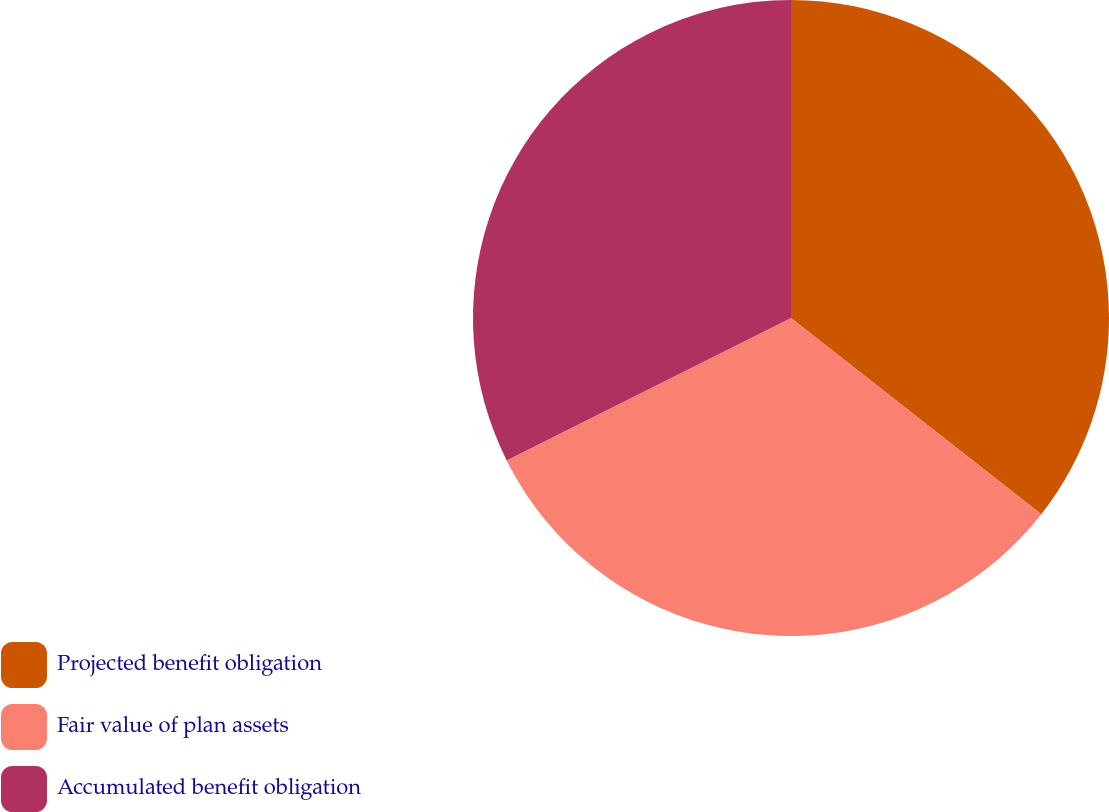<chart> <loc_0><loc_0><loc_500><loc_500><pie_chart><fcel>Projected benefit obligation<fcel>Fair value of plan assets<fcel>Accumulated benefit obligation<nl><fcel>35.58%<fcel>32.03%<fcel>32.39%<nl></chart> 